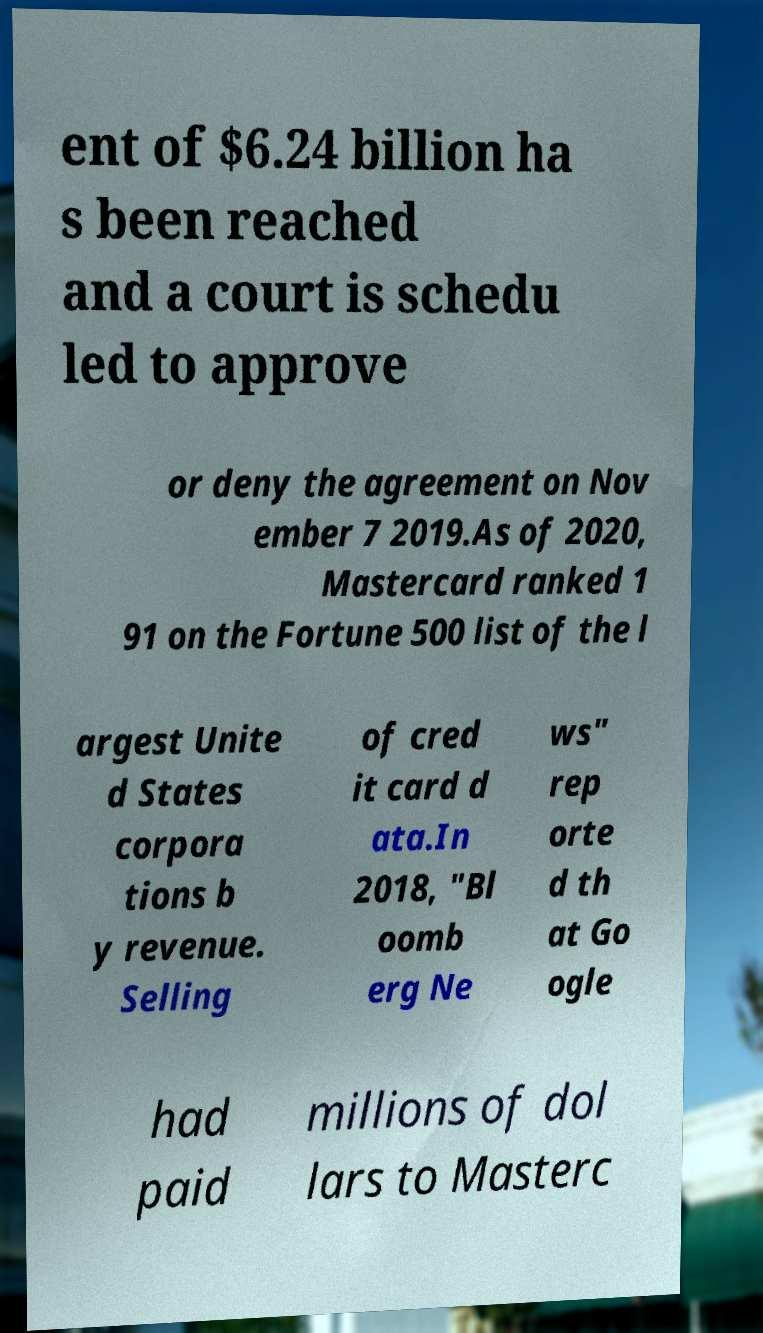For documentation purposes, I need the text within this image transcribed. Could you provide that? ent of $6.24 billion ha s been reached and a court is schedu led to approve or deny the agreement on Nov ember 7 2019.As of 2020, Mastercard ranked 1 91 on the Fortune 500 list of the l argest Unite d States corpora tions b y revenue. Selling of cred it card d ata.In 2018, "Bl oomb erg Ne ws" rep orte d th at Go ogle had paid millions of dol lars to Masterc 